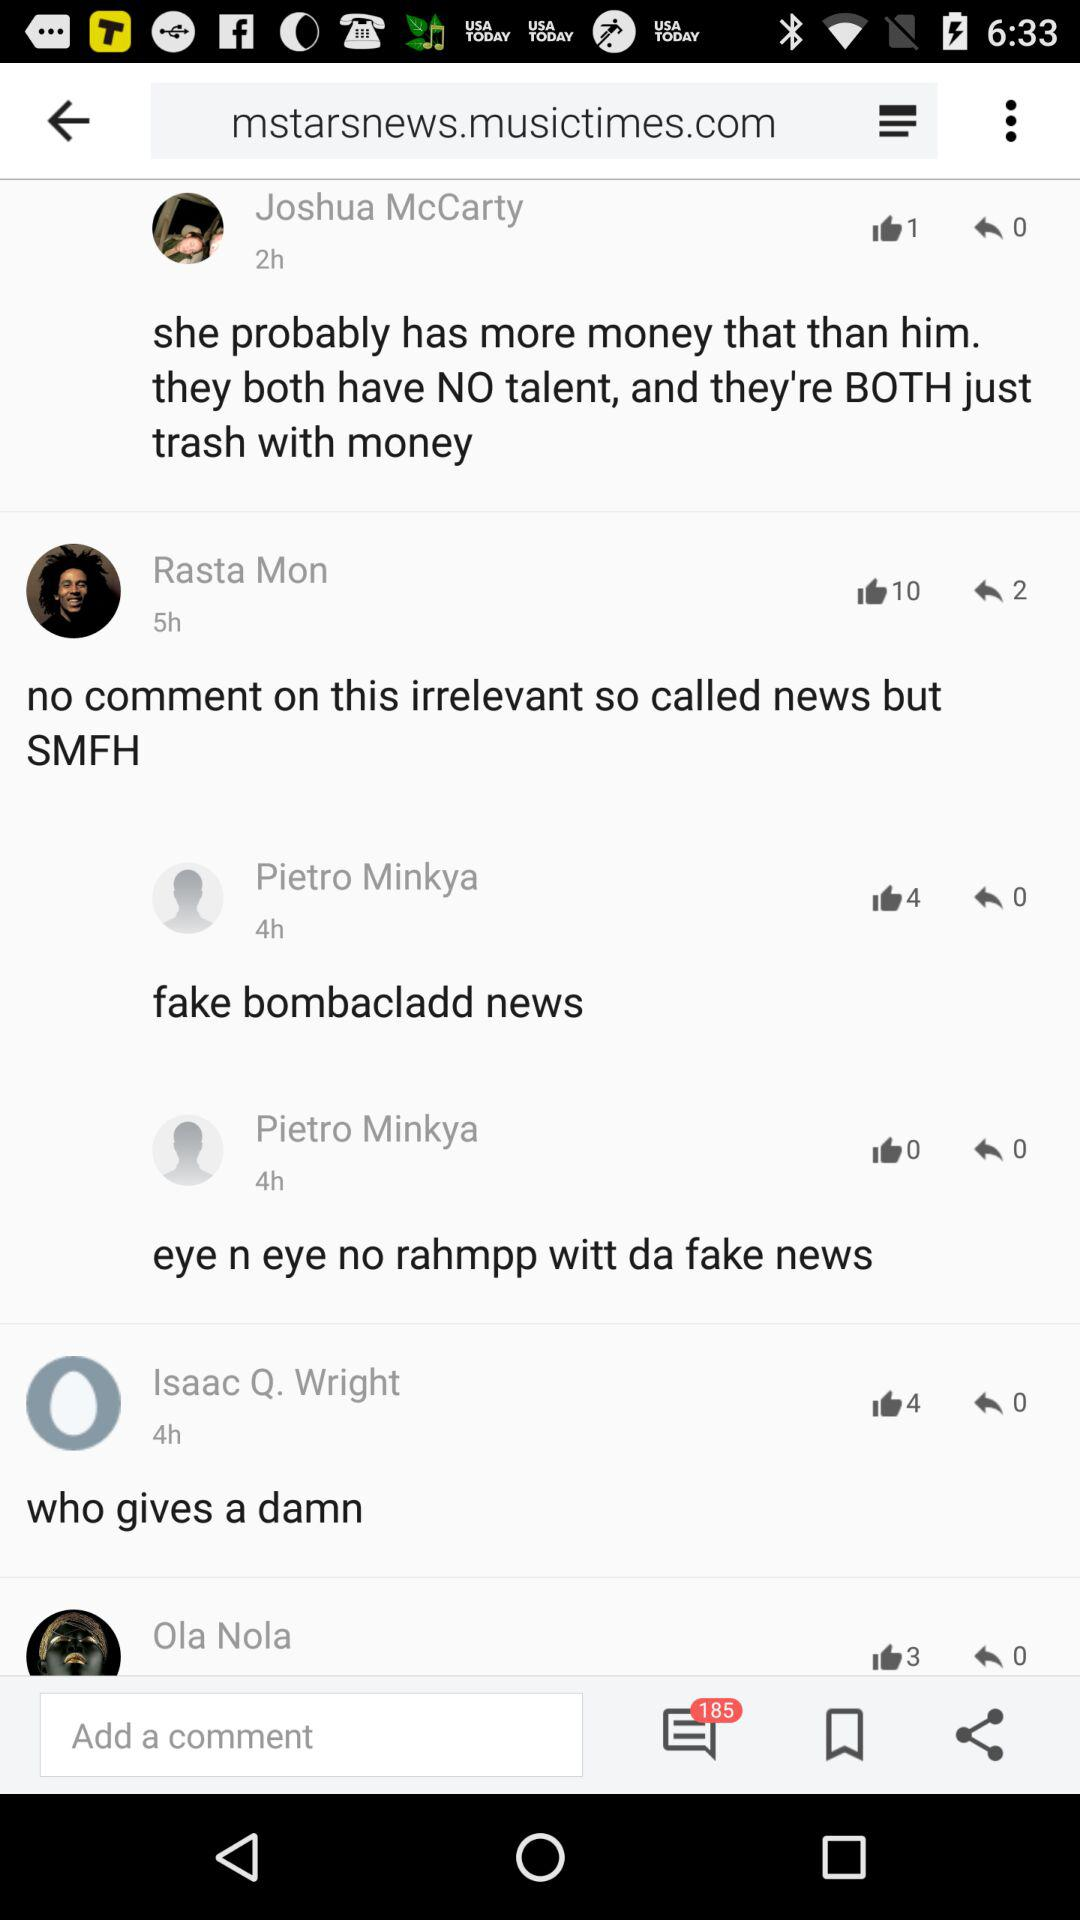How many hours ago did Rasta Mon comment on the post? Rasta Mon commented on the post 5 hours ago. 